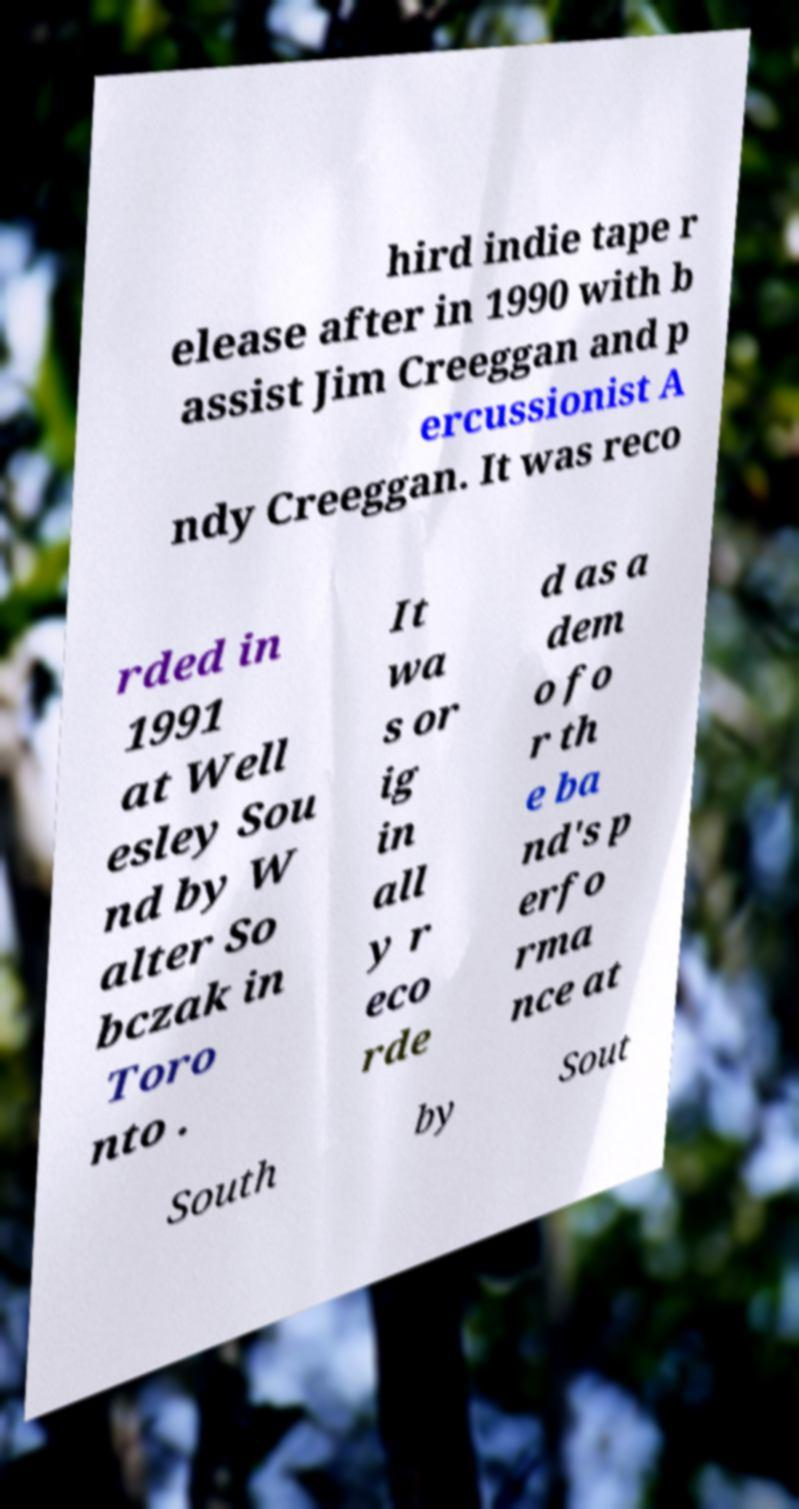Can you read and provide the text displayed in the image?This photo seems to have some interesting text. Can you extract and type it out for me? hird indie tape r elease after in 1990 with b assist Jim Creeggan and p ercussionist A ndy Creeggan. It was reco rded in 1991 at Well esley Sou nd by W alter So bczak in Toro nto . It wa s or ig in all y r eco rde d as a dem o fo r th e ba nd's p erfo rma nce at South by Sout 